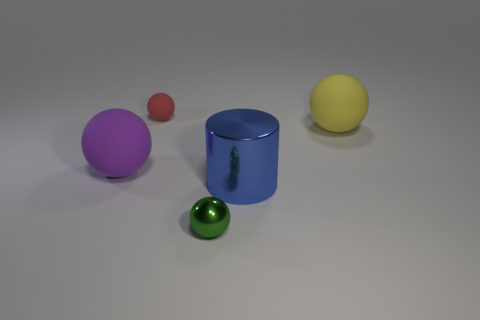Subtract all gray spheres. Subtract all gray cubes. How many spheres are left? 4 Add 3 red things. How many objects exist? 8 Subtract all cylinders. How many objects are left? 4 Subtract all tiny things. Subtract all big yellow rubber balls. How many objects are left? 2 Add 2 big purple matte things. How many big purple matte things are left? 3 Add 1 metal cylinders. How many metal cylinders exist? 2 Subtract 1 blue cylinders. How many objects are left? 4 